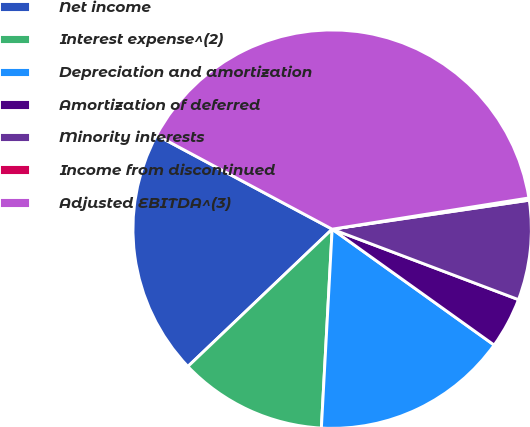<chart> <loc_0><loc_0><loc_500><loc_500><pie_chart><fcel>Net income<fcel>Interest expense^(2)<fcel>Depreciation and amortization<fcel>Amortization of deferred<fcel>Minority interests<fcel>Income from discontinued<fcel>Adjusted EBITDA^(3)<nl><fcel>19.93%<fcel>12.03%<fcel>15.98%<fcel>4.13%<fcel>8.08%<fcel>0.18%<fcel>39.68%<nl></chart> 